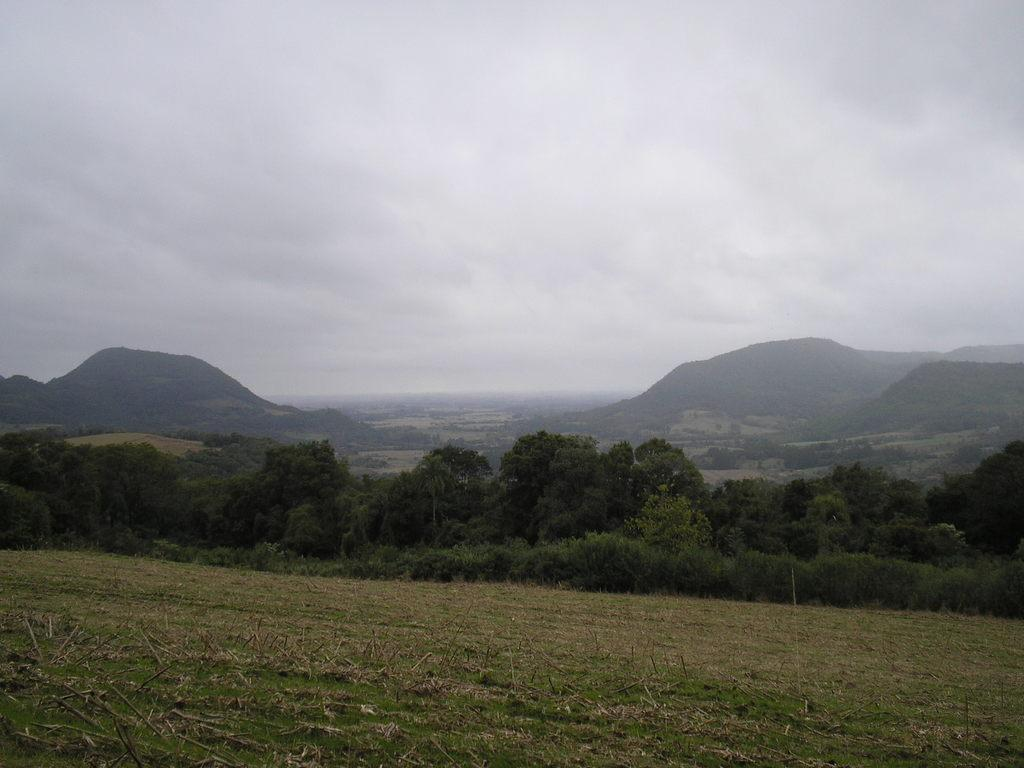What is the condition of the sky in the image? The sky is cloudy in the image. What type of vegetation can be seen in the image? There are trees visible in the image. What geographical feature can be seen in the distance? There are mountains in the distance in the image. Can you tell me how many cats are sitting on the branches of the trees in the image? There are no cats present in the image; only trees and mountains can be seen. 